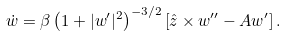<formula> <loc_0><loc_0><loc_500><loc_500>\dot { w } = \beta \left ( 1 + | { w } ^ { \prime } | ^ { 2 } \right ) ^ { - 3 / 2 } \left [ \hat { z } \times { w } ^ { \prime \prime } - A { w } ^ { \prime } \right ] .</formula> 